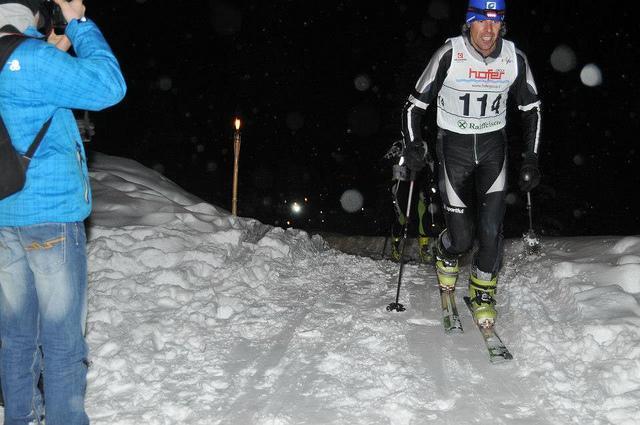How many people with blue shirts?
Give a very brief answer. 1. How many people can be seen?
Give a very brief answer. 3. 